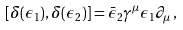<formula> <loc_0><loc_0><loc_500><loc_500>\left [ \delta ( \epsilon _ { 1 } ) , \delta ( \epsilon _ { 2 } ) \right ] = \bar { \epsilon } _ { 2 } \gamma ^ { \mu } \epsilon _ { 1 } \partial _ { \mu } \, ,</formula> 